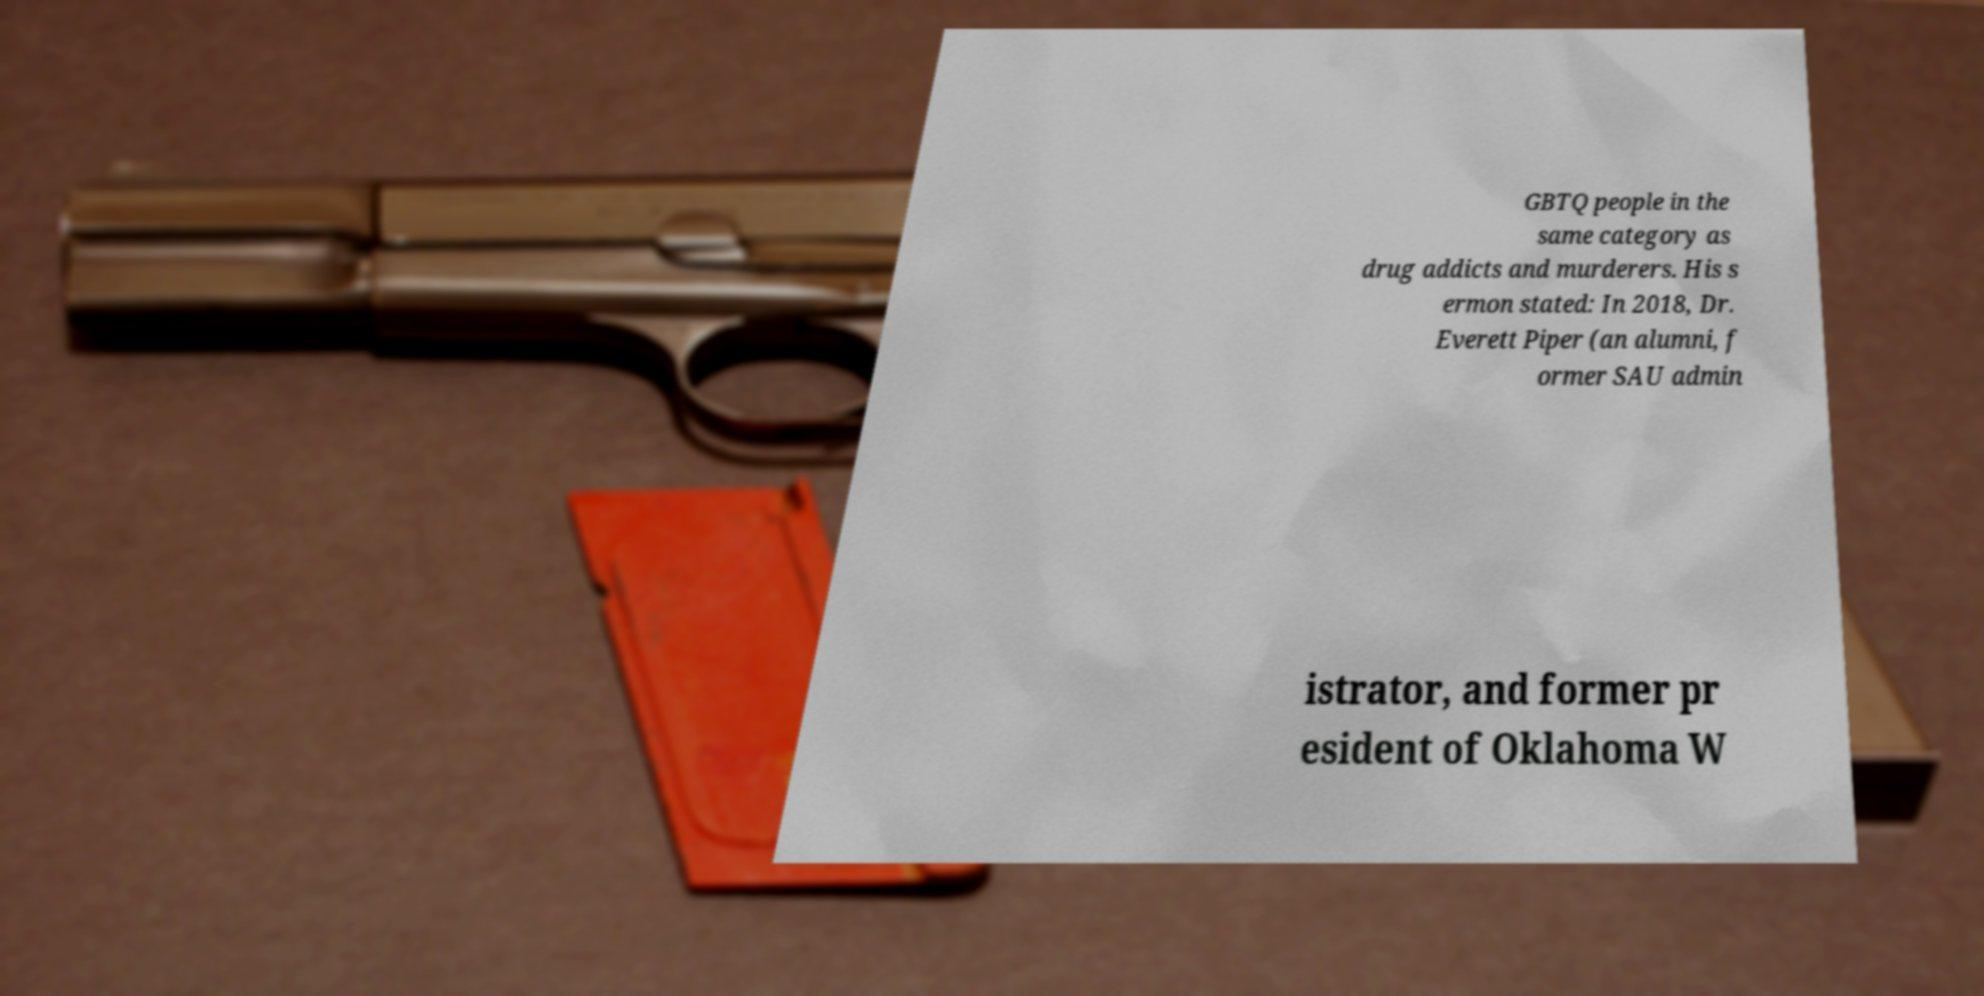Please identify and transcribe the text found in this image. GBTQ people in the same category as drug addicts and murderers. His s ermon stated: In 2018, Dr. Everett Piper (an alumni, f ormer SAU admin istrator, and former pr esident of Oklahoma W 